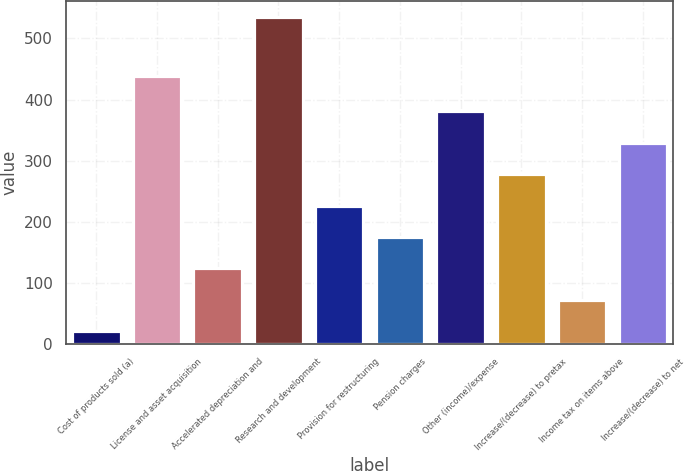Convert chart. <chart><loc_0><loc_0><loc_500><loc_500><bar_chart><fcel>Cost of products sold (a)<fcel>License and asset acquisition<fcel>Accelerated depreciation and<fcel>Research and development<fcel>Provision for restructuring<fcel>Pension charges<fcel>Other (income)/expense<fcel>Increase/(decrease) to pretax<fcel>Income tax on items above<fcel>Increase/(decrease) to net<nl><fcel>21<fcel>439<fcel>123.8<fcel>535<fcel>226.6<fcel>175.2<fcel>380.8<fcel>278<fcel>72.4<fcel>329.4<nl></chart> 